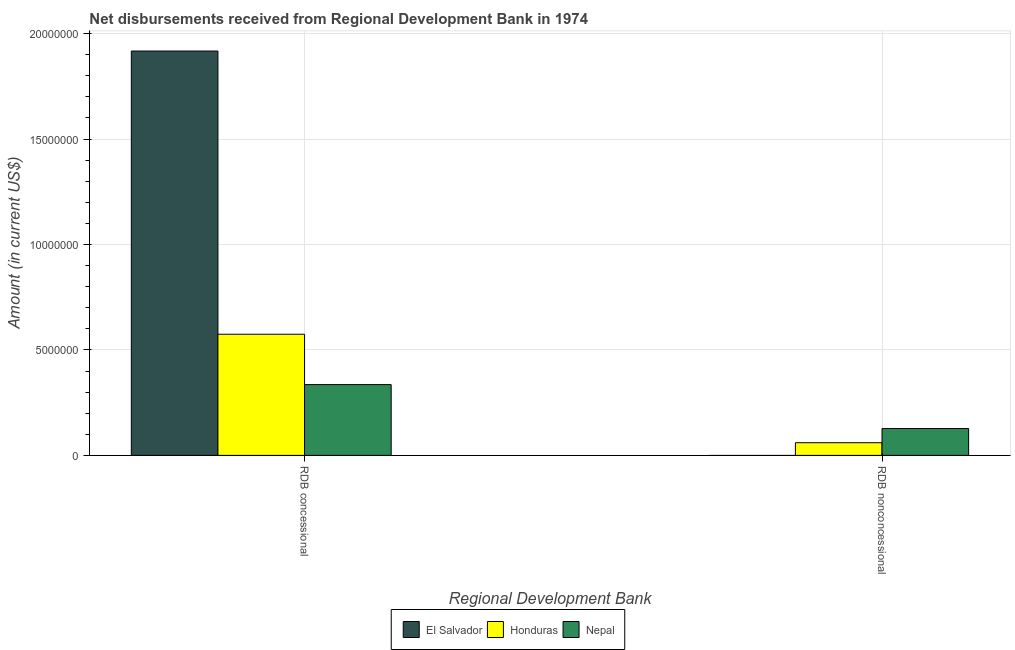How many different coloured bars are there?
Your answer should be compact. 3. How many groups of bars are there?
Your answer should be very brief. 2. Are the number of bars on each tick of the X-axis equal?
Ensure brevity in your answer.  No. How many bars are there on the 2nd tick from the left?
Keep it short and to the point. 2. What is the label of the 2nd group of bars from the left?
Ensure brevity in your answer.  RDB nonconcessional. What is the net non concessional disbursements from rdb in El Salvador?
Your response must be concise. 0. Across all countries, what is the maximum net concessional disbursements from rdb?
Your answer should be compact. 1.92e+07. In which country was the net non concessional disbursements from rdb maximum?
Your answer should be very brief. Nepal. What is the total net non concessional disbursements from rdb in the graph?
Provide a short and direct response. 1.87e+06. What is the difference between the net non concessional disbursements from rdb in Honduras and that in Nepal?
Your response must be concise. -6.72e+05. What is the difference between the net concessional disbursements from rdb in Nepal and the net non concessional disbursements from rdb in Honduras?
Offer a terse response. 2.76e+06. What is the average net non concessional disbursements from rdb per country?
Provide a succinct answer. 6.25e+05. What is the difference between the net non concessional disbursements from rdb and net concessional disbursements from rdb in Honduras?
Offer a very short reply. -5.14e+06. In how many countries, is the net concessional disbursements from rdb greater than 15000000 US$?
Your response must be concise. 1. What is the ratio of the net concessional disbursements from rdb in Nepal to that in Honduras?
Your answer should be compact. 0.58. In how many countries, is the net non concessional disbursements from rdb greater than the average net non concessional disbursements from rdb taken over all countries?
Offer a terse response. 1. Are all the bars in the graph horizontal?
Provide a short and direct response. No. What is the difference between two consecutive major ticks on the Y-axis?
Your answer should be compact. 5.00e+06. Does the graph contain any zero values?
Give a very brief answer. Yes. Does the graph contain grids?
Provide a succinct answer. Yes. How many legend labels are there?
Your answer should be compact. 3. How are the legend labels stacked?
Your response must be concise. Horizontal. What is the title of the graph?
Give a very brief answer. Net disbursements received from Regional Development Bank in 1974. Does "Jordan" appear as one of the legend labels in the graph?
Ensure brevity in your answer.  No. What is the label or title of the X-axis?
Keep it short and to the point. Regional Development Bank. What is the label or title of the Y-axis?
Give a very brief answer. Amount (in current US$). What is the Amount (in current US$) in El Salvador in RDB concessional?
Ensure brevity in your answer.  1.92e+07. What is the Amount (in current US$) of Honduras in RDB concessional?
Ensure brevity in your answer.  5.74e+06. What is the Amount (in current US$) of Nepal in RDB concessional?
Your response must be concise. 3.36e+06. What is the Amount (in current US$) of El Salvador in RDB nonconcessional?
Make the answer very short. 0. What is the Amount (in current US$) of Honduras in RDB nonconcessional?
Keep it short and to the point. 6.01e+05. What is the Amount (in current US$) of Nepal in RDB nonconcessional?
Give a very brief answer. 1.27e+06. Across all Regional Development Bank, what is the maximum Amount (in current US$) in El Salvador?
Your answer should be compact. 1.92e+07. Across all Regional Development Bank, what is the maximum Amount (in current US$) of Honduras?
Your response must be concise. 5.74e+06. Across all Regional Development Bank, what is the maximum Amount (in current US$) of Nepal?
Offer a very short reply. 3.36e+06. Across all Regional Development Bank, what is the minimum Amount (in current US$) in El Salvador?
Offer a very short reply. 0. Across all Regional Development Bank, what is the minimum Amount (in current US$) in Honduras?
Provide a short and direct response. 6.01e+05. Across all Regional Development Bank, what is the minimum Amount (in current US$) of Nepal?
Provide a succinct answer. 1.27e+06. What is the total Amount (in current US$) of El Salvador in the graph?
Keep it short and to the point. 1.92e+07. What is the total Amount (in current US$) in Honduras in the graph?
Give a very brief answer. 6.35e+06. What is the total Amount (in current US$) in Nepal in the graph?
Your answer should be compact. 4.63e+06. What is the difference between the Amount (in current US$) of Honduras in RDB concessional and that in RDB nonconcessional?
Ensure brevity in your answer.  5.14e+06. What is the difference between the Amount (in current US$) of Nepal in RDB concessional and that in RDB nonconcessional?
Offer a very short reply. 2.08e+06. What is the difference between the Amount (in current US$) in El Salvador in RDB concessional and the Amount (in current US$) in Honduras in RDB nonconcessional?
Your response must be concise. 1.86e+07. What is the difference between the Amount (in current US$) in El Salvador in RDB concessional and the Amount (in current US$) in Nepal in RDB nonconcessional?
Your response must be concise. 1.79e+07. What is the difference between the Amount (in current US$) in Honduras in RDB concessional and the Amount (in current US$) in Nepal in RDB nonconcessional?
Your answer should be very brief. 4.47e+06. What is the average Amount (in current US$) in El Salvador per Regional Development Bank?
Provide a short and direct response. 9.59e+06. What is the average Amount (in current US$) of Honduras per Regional Development Bank?
Your answer should be very brief. 3.17e+06. What is the average Amount (in current US$) in Nepal per Regional Development Bank?
Provide a short and direct response. 2.32e+06. What is the difference between the Amount (in current US$) in El Salvador and Amount (in current US$) in Honduras in RDB concessional?
Offer a terse response. 1.34e+07. What is the difference between the Amount (in current US$) in El Salvador and Amount (in current US$) in Nepal in RDB concessional?
Provide a short and direct response. 1.58e+07. What is the difference between the Amount (in current US$) in Honduras and Amount (in current US$) in Nepal in RDB concessional?
Ensure brevity in your answer.  2.39e+06. What is the difference between the Amount (in current US$) in Honduras and Amount (in current US$) in Nepal in RDB nonconcessional?
Provide a short and direct response. -6.72e+05. What is the ratio of the Amount (in current US$) in Honduras in RDB concessional to that in RDB nonconcessional?
Offer a very short reply. 9.56. What is the ratio of the Amount (in current US$) in Nepal in RDB concessional to that in RDB nonconcessional?
Give a very brief answer. 2.64. What is the difference between the highest and the second highest Amount (in current US$) of Honduras?
Your answer should be very brief. 5.14e+06. What is the difference between the highest and the second highest Amount (in current US$) of Nepal?
Your answer should be compact. 2.08e+06. What is the difference between the highest and the lowest Amount (in current US$) in El Salvador?
Make the answer very short. 1.92e+07. What is the difference between the highest and the lowest Amount (in current US$) of Honduras?
Provide a succinct answer. 5.14e+06. What is the difference between the highest and the lowest Amount (in current US$) of Nepal?
Give a very brief answer. 2.08e+06. 